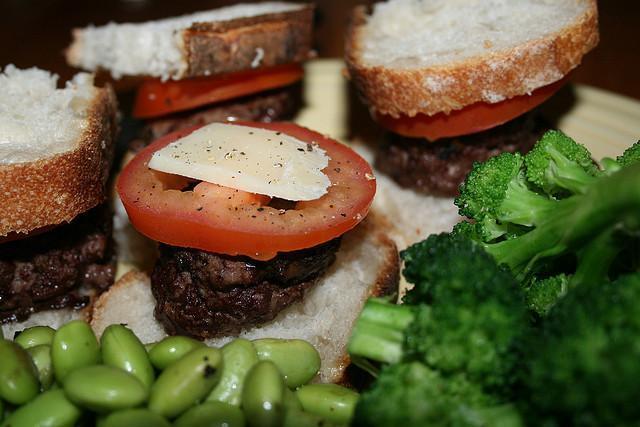How many sandwiches are visible?
Give a very brief answer. 4. How many broccolis are visible?
Give a very brief answer. 2. 